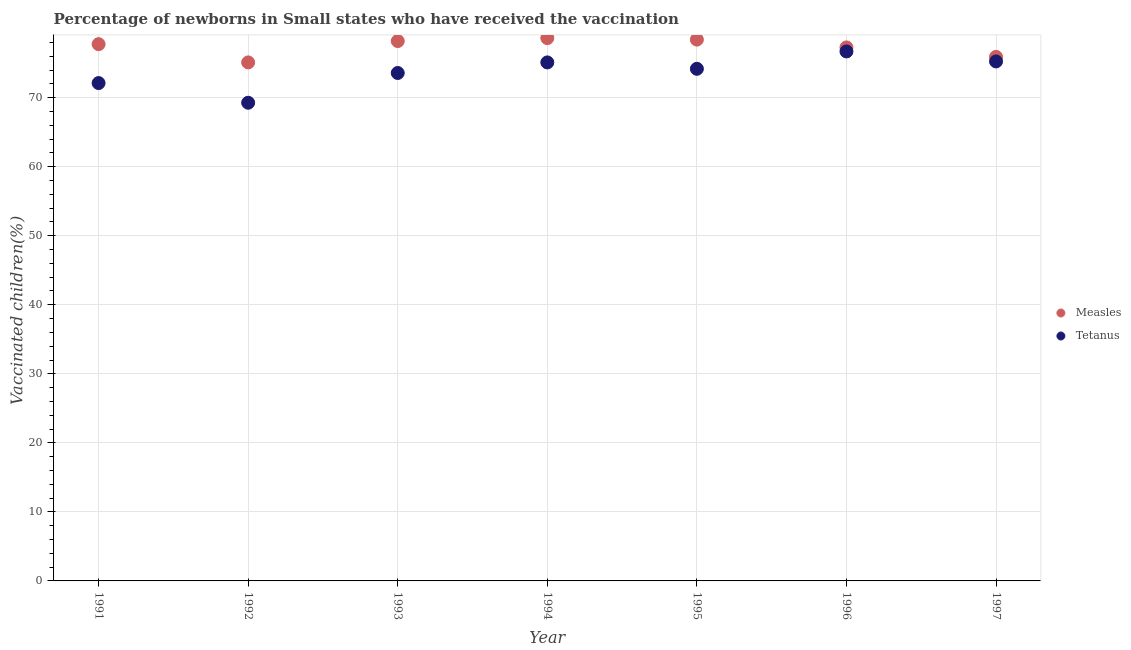Is the number of dotlines equal to the number of legend labels?
Offer a terse response. Yes. What is the percentage of newborns who received vaccination for tetanus in 1991?
Offer a terse response. 72.12. Across all years, what is the maximum percentage of newborns who received vaccination for tetanus?
Your answer should be compact. 76.7. Across all years, what is the minimum percentage of newborns who received vaccination for measles?
Provide a short and direct response. 75.11. In which year was the percentage of newborns who received vaccination for tetanus minimum?
Give a very brief answer. 1992. What is the total percentage of newborns who received vaccination for measles in the graph?
Your answer should be very brief. 541.33. What is the difference between the percentage of newborns who received vaccination for tetanus in 1992 and that in 1996?
Keep it short and to the point. -7.43. What is the difference between the percentage of newborns who received vaccination for tetanus in 1993 and the percentage of newborns who received vaccination for measles in 1992?
Your answer should be compact. -1.53. What is the average percentage of newborns who received vaccination for measles per year?
Provide a succinct answer. 77.33. In the year 1994, what is the difference between the percentage of newborns who received vaccination for measles and percentage of newborns who received vaccination for tetanus?
Offer a terse response. 3.52. What is the ratio of the percentage of newborns who received vaccination for tetanus in 1992 to that in 1996?
Provide a succinct answer. 0.9. What is the difference between the highest and the second highest percentage of newborns who received vaccination for measles?
Give a very brief answer. 0.21. What is the difference between the highest and the lowest percentage of newborns who received vaccination for measles?
Offer a very short reply. 3.52. Is the sum of the percentage of newborns who received vaccination for tetanus in 1993 and 1997 greater than the maximum percentage of newborns who received vaccination for measles across all years?
Your answer should be very brief. Yes. Is the percentage of newborns who received vaccination for measles strictly less than the percentage of newborns who received vaccination for tetanus over the years?
Your answer should be compact. No. How many years are there in the graph?
Keep it short and to the point. 7. Are the values on the major ticks of Y-axis written in scientific E-notation?
Offer a terse response. No. Does the graph contain grids?
Provide a succinct answer. Yes. Where does the legend appear in the graph?
Ensure brevity in your answer.  Center right. How are the legend labels stacked?
Your answer should be compact. Vertical. What is the title of the graph?
Offer a terse response. Percentage of newborns in Small states who have received the vaccination. Does "ODA received" appear as one of the legend labels in the graph?
Give a very brief answer. No. What is the label or title of the X-axis?
Ensure brevity in your answer.  Year. What is the label or title of the Y-axis?
Make the answer very short. Vaccinated children(%)
. What is the Vaccinated children(%)
 in Measles in 1991?
Provide a short and direct response. 77.76. What is the Vaccinated children(%)
 in Tetanus in 1991?
Give a very brief answer. 72.12. What is the Vaccinated children(%)
 in Measles in 1992?
Make the answer very short. 75.11. What is the Vaccinated children(%)
 of Tetanus in 1992?
Ensure brevity in your answer.  69.27. What is the Vaccinated children(%)
 in Measles in 1993?
Keep it short and to the point. 78.21. What is the Vaccinated children(%)
 in Tetanus in 1993?
Your response must be concise. 73.58. What is the Vaccinated children(%)
 of Measles in 1994?
Give a very brief answer. 78.63. What is the Vaccinated children(%)
 of Tetanus in 1994?
Give a very brief answer. 75.11. What is the Vaccinated children(%)
 in Measles in 1995?
Keep it short and to the point. 78.42. What is the Vaccinated children(%)
 of Tetanus in 1995?
Keep it short and to the point. 74.19. What is the Vaccinated children(%)
 in Measles in 1996?
Provide a succinct answer. 77.28. What is the Vaccinated children(%)
 of Tetanus in 1996?
Offer a very short reply. 76.7. What is the Vaccinated children(%)
 in Measles in 1997?
Your answer should be compact. 75.92. What is the Vaccinated children(%)
 in Tetanus in 1997?
Keep it short and to the point. 75.26. Across all years, what is the maximum Vaccinated children(%)
 of Measles?
Provide a succinct answer. 78.63. Across all years, what is the maximum Vaccinated children(%)
 in Tetanus?
Provide a succinct answer. 76.7. Across all years, what is the minimum Vaccinated children(%)
 in Measles?
Your response must be concise. 75.11. Across all years, what is the minimum Vaccinated children(%)
 in Tetanus?
Your answer should be compact. 69.27. What is the total Vaccinated children(%)
 of Measles in the graph?
Give a very brief answer. 541.33. What is the total Vaccinated children(%)
 of Tetanus in the graph?
Provide a succinct answer. 516.23. What is the difference between the Vaccinated children(%)
 in Measles in 1991 and that in 1992?
Give a very brief answer. 2.64. What is the difference between the Vaccinated children(%)
 in Tetanus in 1991 and that in 1992?
Provide a succinct answer. 2.85. What is the difference between the Vaccinated children(%)
 of Measles in 1991 and that in 1993?
Your response must be concise. -0.45. What is the difference between the Vaccinated children(%)
 in Tetanus in 1991 and that in 1993?
Make the answer very short. -1.46. What is the difference between the Vaccinated children(%)
 of Measles in 1991 and that in 1994?
Ensure brevity in your answer.  -0.88. What is the difference between the Vaccinated children(%)
 in Tetanus in 1991 and that in 1994?
Keep it short and to the point. -2.99. What is the difference between the Vaccinated children(%)
 of Measles in 1991 and that in 1995?
Your response must be concise. -0.66. What is the difference between the Vaccinated children(%)
 of Tetanus in 1991 and that in 1995?
Your answer should be compact. -2.07. What is the difference between the Vaccinated children(%)
 in Measles in 1991 and that in 1996?
Ensure brevity in your answer.  0.47. What is the difference between the Vaccinated children(%)
 in Tetanus in 1991 and that in 1996?
Keep it short and to the point. -4.58. What is the difference between the Vaccinated children(%)
 in Measles in 1991 and that in 1997?
Keep it short and to the point. 1.84. What is the difference between the Vaccinated children(%)
 of Tetanus in 1991 and that in 1997?
Your response must be concise. -3.14. What is the difference between the Vaccinated children(%)
 of Measles in 1992 and that in 1993?
Offer a terse response. -3.09. What is the difference between the Vaccinated children(%)
 of Tetanus in 1992 and that in 1993?
Provide a short and direct response. -4.31. What is the difference between the Vaccinated children(%)
 of Measles in 1992 and that in 1994?
Provide a succinct answer. -3.52. What is the difference between the Vaccinated children(%)
 of Tetanus in 1992 and that in 1994?
Your response must be concise. -5.84. What is the difference between the Vaccinated children(%)
 in Measles in 1992 and that in 1995?
Make the answer very short. -3.3. What is the difference between the Vaccinated children(%)
 of Tetanus in 1992 and that in 1995?
Your response must be concise. -4.92. What is the difference between the Vaccinated children(%)
 of Measles in 1992 and that in 1996?
Keep it short and to the point. -2.17. What is the difference between the Vaccinated children(%)
 of Tetanus in 1992 and that in 1996?
Provide a succinct answer. -7.43. What is the difference between the Vaccinated children(%)
 in Measles in 1992 and that in 1997?
Ensure brevity in your answer.  -0.8. What is the difference between the Vaccinated children(%)
 in Tetanus in 1992 and that in 1997?
Your answer should be very brief. -5.98. What is the difference between the Vaccinated children(%)
 in Measles in 1993 and that in 1994?
Provide a succinct answer. -0.43. What is the difference between the Vaccinated children(%)
 of Tetanus in 1993 and that in 1994?
Provide a succinct answer. -1.53. What is the difference between the Vaccinated children(%)
 of Measles in 1993 and that in 1995?
Offer a terse response. -0.21. What is the difference between the Vaccinated children(%)
 of Tetanus in 1993 and that in 1995?
Provide a succinct answer. -0.61. What is the difference between the Vaccinated children(%)
 in Measles in 1993 and that in 1996?
Offer a terse response. 0.92. What is the difference between the Vaccinated children(%)
 of Tetanus in 1993 and that in 1996?
Keep it short and to the point. -3.12. What is the difference between the Vaccinated children(%)
 of Measles in 1993 and that in 1997?
Offer a terse response. 2.29. What is the difference between the Vaccinated children(%)
 of Tetanus in 1993 and that in 1997?
Your response must be concise. -1.67. What is the difference between the Vaccinated children(%)
 of Measles in 1994 and that in 1995?
Provide a succinct answer. 0.21. What is the difference between the Vaccinated children(%)
 of Tetanus in 1994 and that in 1995?
Give a very brief answer. 0.92. What is the difference between the Vaccinated children(%)
 of Measles in 1994 and that in 1996?
Ensure brevity in your answer.  1.35. What is the difference between the Vaccinated children(%)
 of Tetanus in 1994 and that in 1996?
Offer a very short reply. -1.59. What is the difference between the Vaccinated children(%)
 in Measles in 1994 and that in 1997?
Provide a succinct answer. 2.72. What is the difference between the Vaccinated children(%)
 in Tetanus in 1994 and that in 1997?
Keep it short and to the point. -0.14. What is the difference between the Vaccinated children(%)
 in Measles in 1995 and that in 1996?
Provide a succinct answer. 1.13. What is the difference between the Vaccinated children(%)
 of Tetanus in 1995 and that in 1996?
Your answer should be compact. -2.51. What is the difference between the Vaccinated children(%)
 in Measles in 1995 and that in 1997?
Offer a very short reply. 2.5. What is the difference between the Vaccinated children(%)
 of Tetanus in 1995 and that in 1997?
Your answer should be very brief. -1.07. What is the difference between the Vaccinated children(%)
 of Measles in 1996 and that in 1997?
Your answer should be very brief. 1.37. What is the difference between the Vaccinated children(%)
 in Tetanus in 1996 and that in 1997?
Keep it short and to the point. 1.45. What is the difference between the Vaccinated children(%)
 in Measles in 1991 and the Vaccinated children(%)
 in Tetanus in 1992?
Give a very brief answer. 8.49. What is the difference between the Vaccinated children(%)
 in Measles in 1991 and the Vaccinated children(%)
 in Tetanus in 1993?
Offer a terse response. 4.18. What is the difference between the Vaccinated children(%)
 of Measles in 1991 and the Vaccinated children(%)
 of Tetanus in 1994?
Give a very brief answer. 2.65. What is the difference between the Vaccinated children(%)
 in Measles in 1991 and the Vaccinated children(%)
 in Tetanus in 1995?
Give a very brief answer. 3.57. What is the difference between the Vaccinated children(%)
 of Measles in 1991 and the Vaccinated children(%)
 of Tetanus in 1996?
Your answer should be compact. 1.06. What is the difference between the Vaccinated children(%)
 in Measles in 1991 and the Vaccinated children(%)
 in Tetanus in 1997?
Offer a terse response. 2.5. What is the difference between the Vaccinated children(%)
 in Measles in 1992 and the Vaccinated children(%)
 in Tetanus in 1993?
Give a very brief answer. 1.53. What is the difference between the Vaccinated children(%)
 in Measles in 1992 and the Vaccinated children(%)
 in Tetanus in 1994?
Provide a short and direct response. 0. What is the difference between the Vaccinated children(%)
 in Measles in 1992 and the Vaccinated children(%)
 in Tetanus in 1995?
Your answer should be compact. 0.93. What is the difference between the Vaccinated children(%)
 of Measles in 1992 and the Vaccinated children(%)
 of Tetanus in 1996?
Provide a short and direct response. -1.59. What is the difference between the Vaccinated children(%)
 of Measles in 1992 and the Vaccinated children(%)
 of Tetanus in 1997?
Keep it short and to the point. -0.14. What is the difference between the Vaccinated children(%)
 of Measles in 1993 and the Vaccinated children(%)
 of Tetanus in 1994?
Your answer should be very brief. 3.09. What is the difference between the Vaccinated children(%)
 of Measles in 1993 and the Vaccinated children(%)
 of Tetanus in 1995?
Give a very brief answer. 4.02. What is the difference between the Vaccinated children(%)
 of Measles in 1993 and the Vaccinated children(%)
 of Tetanus in 1996?
Your response must be concise. 1.5. What is the difference between the Vaccinated children(%)
 of Measles in 1993 and the Vaccinated children(%)
 of Tetanus in 1997?
Ensure brevity in your answer.  2.95. What is the difference between the Vaccinated children(%)
 of Measles in 1994 and the Vaccinated children(%)
 of Tetanus in 1995?
Make the answer very short. 4.45. What is the difference between the Vaccinated children(%)
 in Measles in 1994 and the Vaccinated children(%)
 in Tetanus in 1996?
Offer a terse response. 1.93. What is the difference between the Vaccinated children(%)
 in Measles in 1994 and the Vaccinated children(%)
 in Tetanus in 1997?
Your answer should be compact. 3.38. What is the difference between the Vaccinated children(%)
 of Measles in 1995 and the Vaccinated children(%)
 of Tetanus in 1996?
Provide a succinct answer. 1.72. What is the difference between the Vaccinated children(%)
 in Measles in 1995 and the Vaccinated children(%)
 in Tetanus in 1997?
Offer a very short reply. 3.16. What is the difference between the Vaccinated children(%)
 of Measles in 1996 and the Vaccinated children(%)
 of Tetanus in 1997?
Offer a very short reply. 2.03. What is the average Vaccinated children(%)
 in Measles per year?
Ensure brevity in your answer.  77.33. What is the average Vaccinated children(%)
 in Tetanus per year?
Make the answer very short. 73.75. In the year 1991, what is the difference between the Vaccinated children(%)
 in Measles and Vaccinated children(%)
 in Tetanus?
Your answer should be compact. 5.64. In the year 1992, what is the difference between the Vaccinated children(%)
 of Measles and Vaccinated children(%)
 of Tetanus?
Give a very brief answer. 5.84. In the year 1993, what is the difference between the Vaccinated children(%)
 of Measles and Vaccinated children(%)
 of Tetanus?
Your answer should be compact. 4.63. In the year 1994, what is the difference between the Vaccinated children(%)
 of Measles and Vaccinated children(%)
 of Tetanus?
Your answer should be very brief. 3.52. In the year 1995, what is the difference between the Vaccinated children(%)
 in Measles and Vaccinated children(%)
 in Tetanus?
Provide a short and direct response. 4.23. In the year 1996, what is the difference between the Vaccinated children(%)
 of Measles and Vaccinated children(%)
 of Tetanus?
Offer a very short reply. 0.58. In the year 1997, what is the difference between the Vaccinated children(%)
 in Measles and Vaccinated children(%)
 in Tetanus?
Your response must be concise. 0.66. What is the ratio of the Vaccinated children(%)
 in Measles in 1991 to that in 1992?
Keep it short and to the point. 1.04. What is the ratio of the Vaccinated children(%)
 in Tetanus in 1991 to that in 1992?
Offer a terse response. 1.04. What is the ratio of the Vaccinated children(%)
 of Measles in 1991 to that in 1993?
Your response must be concise. 0.99. What is the ratio of the Vaccinated children(%)
 in Tetanus in 1991 to that in 1993?
Offer a very short reply. 0.98. What is the ratio of the Vaccinated children(%)
 in Measles in 1991 to that in 1994?
Offer a terse response. 0.99. What is the ratio of the Vaccinated children(%)
 in Tetanus in 1991 to that in 1994?
Give a very brief answer. 0.96. What is the ratio of the Vaccinated children(%)
 of Tetanus in 1991 to that in 1995?
Make the answer very short. 0.97. What is the ratio of the Vaccinated children(%)
 of Measles in 1991 to that in 1996?
Keep it short and to the point. 1.01. What is the ratio of the Vaccinated children(%)
 in Tetanus in 1991 to that in 1996?
Provide a succinct answer. 0.94. What is the ratio of the Vaccinated children(%)
 of Measles in 1991 to that in 1997?
Keep it short and to the point. 1.02. What is the ratio of the Vaccinated children(%)
 in Measles in 1992 to that in 1993?
Offer a very short reply. 0.96. What is the ratio of the Vaccinated children(%)
 in Tetanus in 1992 to that in 1993?
Your answer should be very brief. 0.94. What is the ratio of the Vaccinated children(%)
 of Measles in 1992 to that in 1994?
Your answer should be compact. 0.96. What is the ratio of the Vaccinated children(%)
 of Tetanus in 1992 to that in 1994?
Provide a succinct answer. 0.92. What is the ratio of the Vaccinated children(%)
 of Measles in 1992 to that in 1995?
Keep it short and to the point. 0.96. What is the ratio of the Vaccinated children(%)
 in Tetanus in 1992 to that in 1995?
Keep it short and to the point. 0.93. What is the ratio of the Vaccinated children(%)
 of Measles in 1992 to that in 1996?
Offer a terse response. 0.97. What is the ratio of the Vaccinated children(%)
 of Tetanus in 1992 to that in 1996?
Offer a very short reply. 0.9. What is the ratio of the Vaccinated children(%)
 in Measles in 1992 to that in 1997?
Keep it short and to the point. 0.99. What is the ratio of the Vaccinated children(%)
 in Tetanus in 1992 to that in 1997?
Your answer should be compact. 0.92. What is the ratio of the Vaccinated children(%)
 of Measles in 1993 to that in 1994?
Provide a short and direct response. 0.99. What is the ratio of the Vaccinated children(%)
 in Tetanus in 1993 to that in 1994?
Make the answer very short. 0.98. What is the ratio of the Vaccinated children(%)
 in Measles in 1993 to that in 1995?
Make the answer very short. 1. What is the ratio of the Vaccinated children(%)
 of Tetanus in 1993 to that in 1995?
Provide a short and direct response. 0.99. What is the ratio of the Vaccinated children(%)
 of Measles in 1993 to that in 1996?
Offer a terse response. 1.01. What is the ratio of the Vaccinated children(%)
 in Tetanus in 1993 to that in 1996?
Give a very brief answer. 0.96. What is the ratio of the Vaccinated children(%)
 of Measles in 1993 to that in 1997?
Keep it short and to the point. 1.03. What is the ratio of the Vaccinated children(%)
 of Tetanus in 1993 to that in 1997?
Offer a very short reply. 0.98. What is the ratio of the Vaccinated children(%)
 of Measles in 1994 to that in 1995?
Keep it short and to the point. 1. What is the ratio of the Vaccinated children(%)
 in Tetanus in 1994 to that in 1995?
Offer a terse response. 1.01. What is the ratio of the Vaccinated children(%)
 in Measles in 1994 to that in 1996?
Give a very brief answer. 1.02. What is the ratio of the Vaccinated children(%)
 in Tetanus in 1994 to that in 1996?
Your answer should be compact. 0.98. What is the ratio of the Vaccinated children(%)
 of Measles in 1994 to that in 1997?
Your response must be concise. 1.04. What is the ratio of the Vaccinated children(%)
 in Measles in 1995 to that in 1996?
Offer a terse response. 1.01. What is the ratio of the Vaccinated children(%)
 of Tetanus in 1995 to that in 1996?
Provide a short and direct response. 0.97. What is the ratio of the Vaccinated children(%)
 in Measles in 1995 to that in 1997?
Your answer should be very brief. 1.03. What is the ratio of the Vaccinated children(%)
 in Tetanus in 1995 to that in 1997?
Provide a succinct answer. 0.99. What is the ratio of the Vaccinated children(%)
 in Tetanus in 1996 to that in 1997?
Keep it short and to the point. 1.02. What is the difference between the highest and the second highest Vaccinated children(%)
 in Measles?
Keep it short and to the point. 0.21. What is the difference between the highest and the second highest Vaccinated children(%)
 in Tetanus?
Your answer should be compact. 1.45. What is the difference between the highest and the lowest Vaccinated children(%)
 in Measles?
Make the answer very short. 3.52. What is the difference between the highest and the lowest Vaccinated children(%)
 in Tetanus?
Your answer should be very brief. 7.43. 